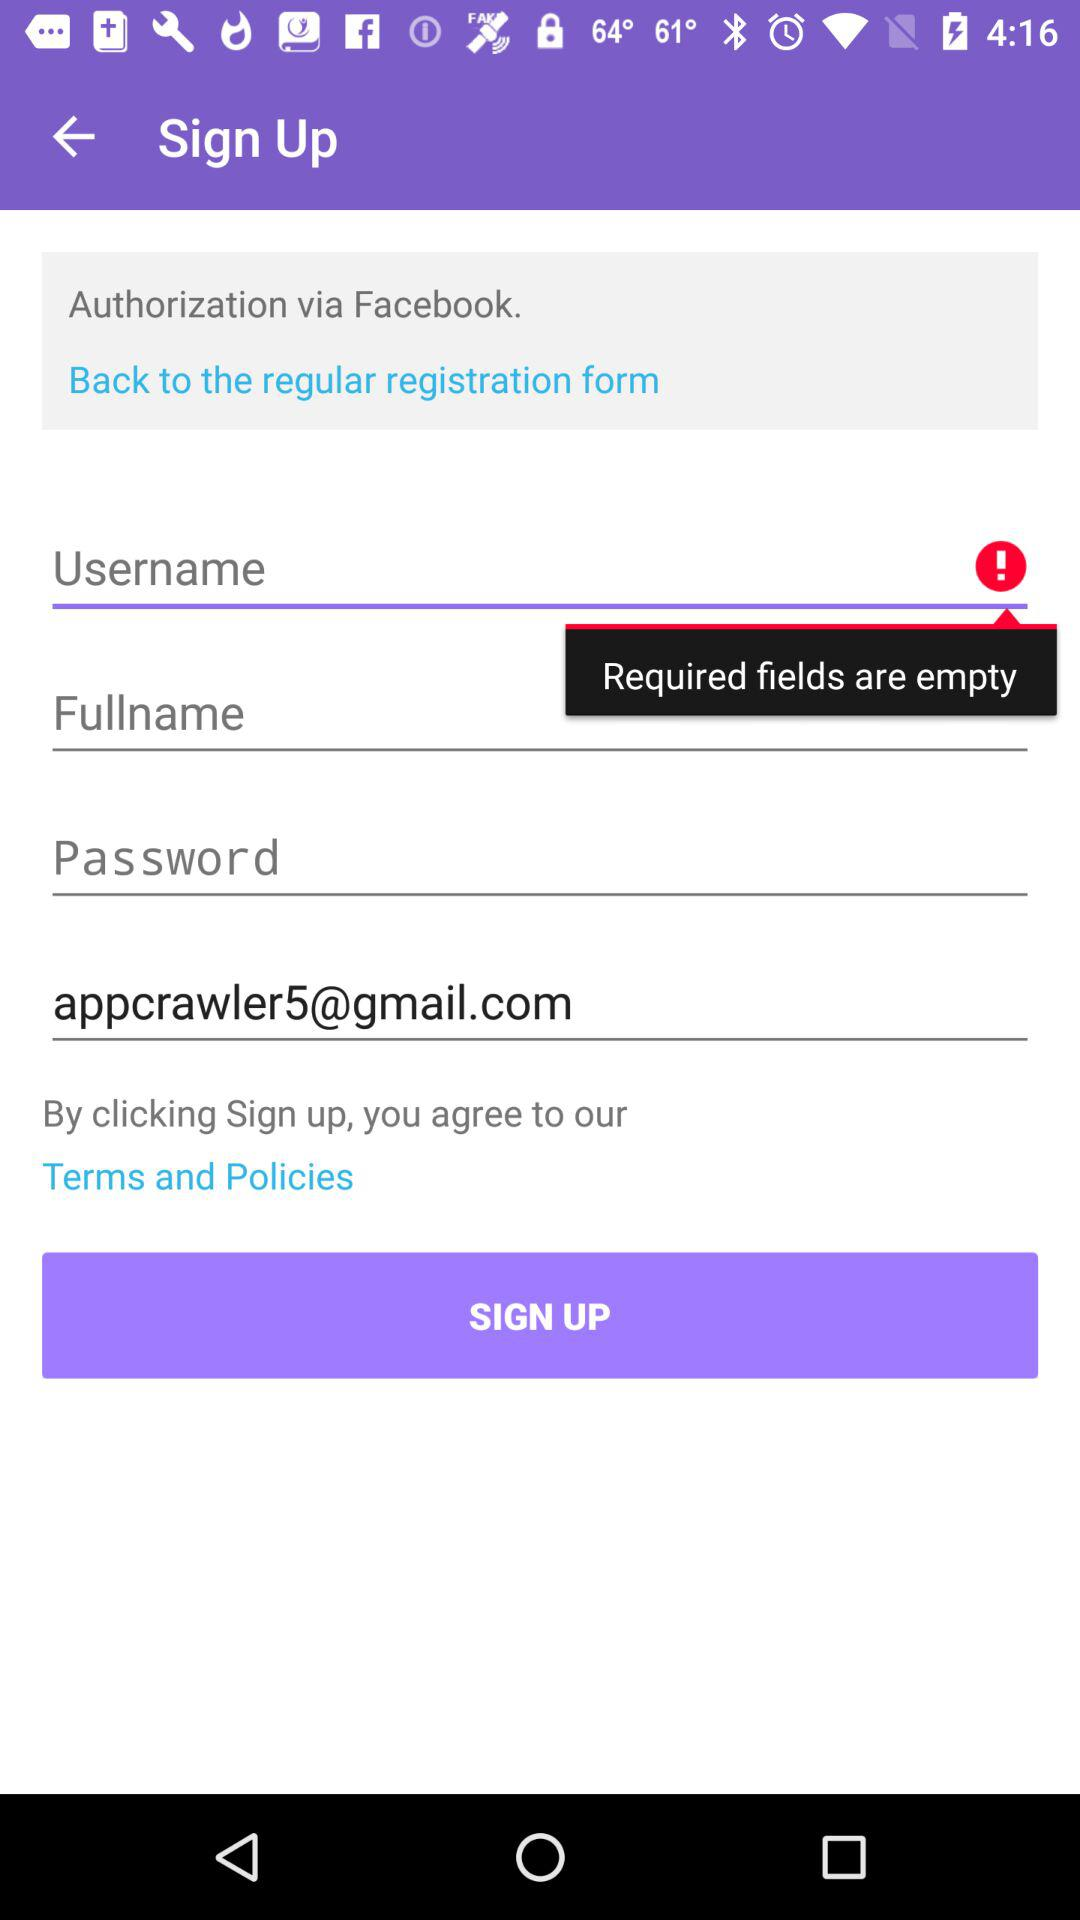What is the given email address to sign in? The given email address to sign in is appcrawler5@gmail.com. 